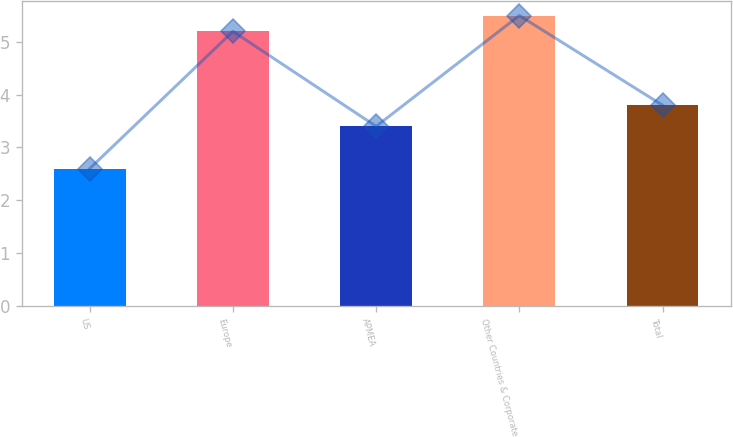Convert chart. <chart><loc_0><loc_0><loc_500><loc_500><bar_chart><fcel>US<fcel>Europe<fcel>APMEA<fcel>Other Countries & Corporate<fcel>Total<nl><fcel>2.6<fcel>5.2<fcel>3.4<fcel>5.5<fcel>3.8<nl></chart> 